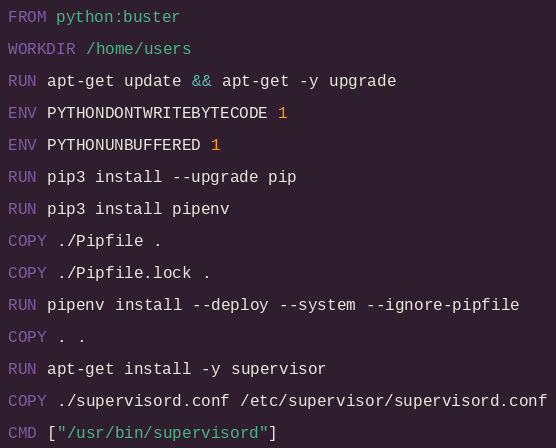<code> <loc_0><loc_0><loc_500><loc_500><_Dockerfile_>FROM python:buster

WORKDIR /home/users

RUN apt-get update && apt-get -y upgrade

ENV PYTHONDONTWRITEBYTECODE 1

ENV PYTHONUNBUFFERED 1

RUN pip3 install --upgrade pip

RUN pip3 install pipenv

COPY ./Pipfile .

COPY ./Pipfile.lock .

RUN pipenv install --deploy --system --ignore-pipfile

COPY . .

RUN apt-get install -y supervisor

COPY ./supervisord.conf /etc/supervisor/supervisord.conf

CMD ["/usr/bin/supervisord"]
</code> 